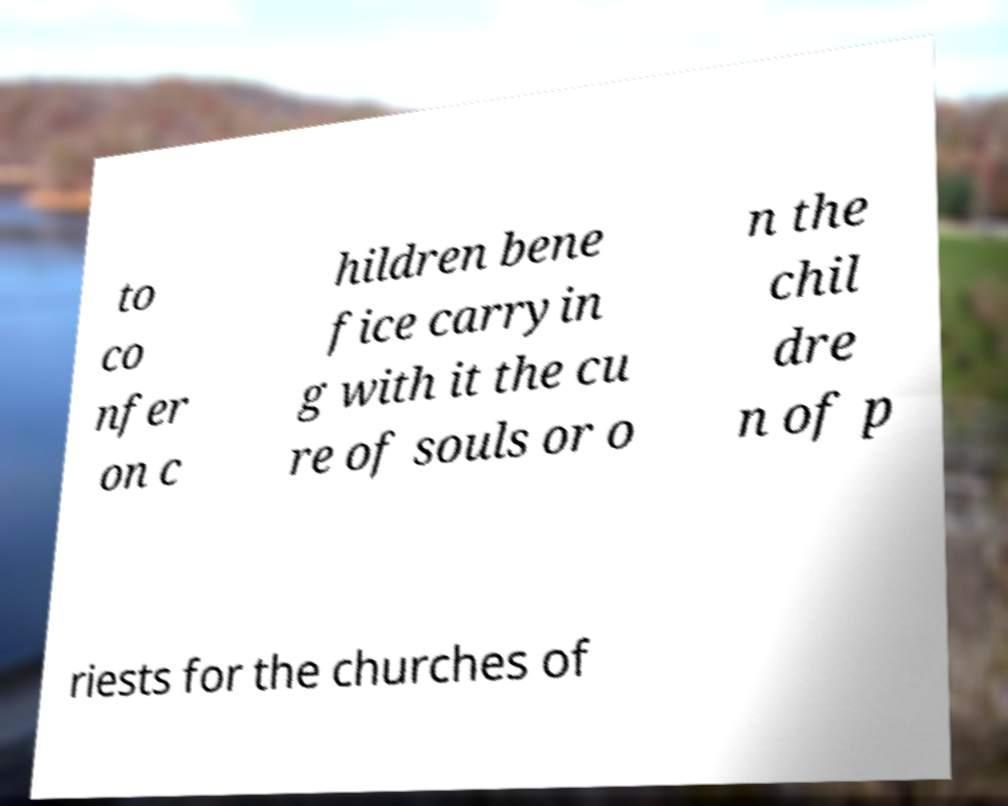Could you assist in decoding the text presented in this image and type it out clearly? to co nfer on c hildren bene fice carryin g with it the cu re of souls or o n the chil dre n of p riests for the churches of 